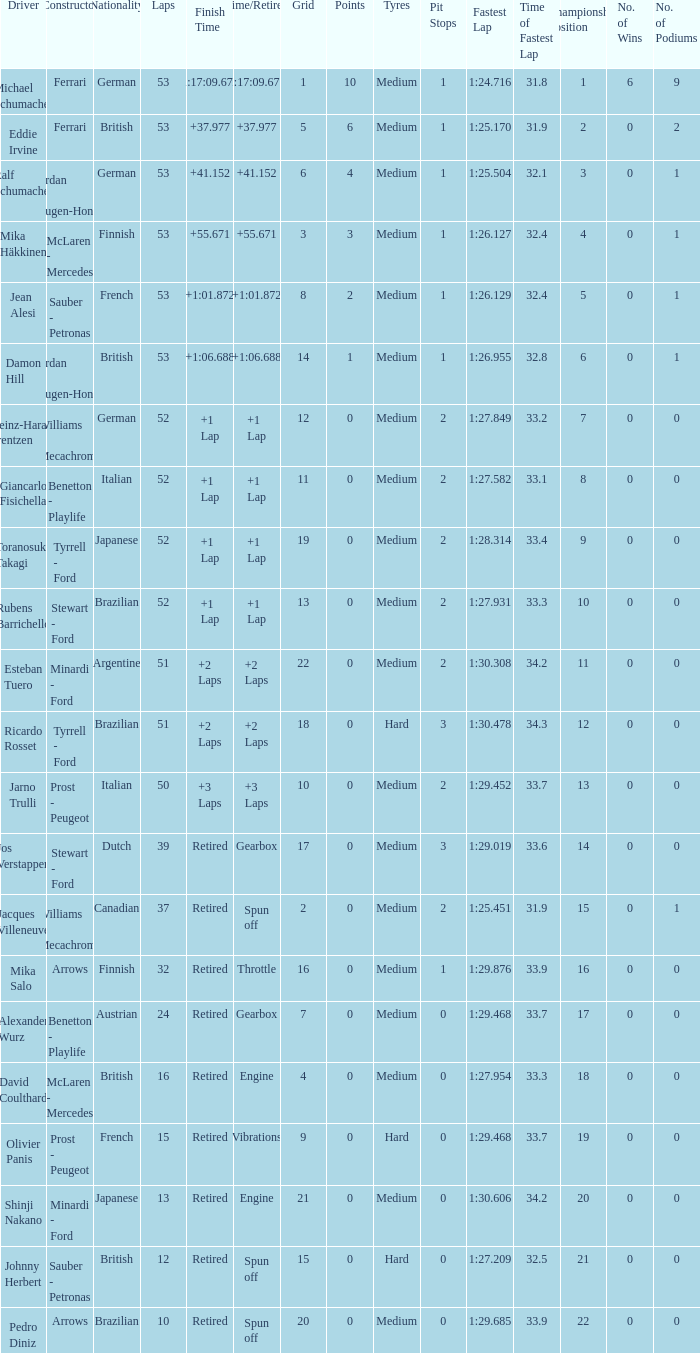Would you be able to parse every entry in this table? {'header': ['Driver', 'Constructor', 'Nationality', 'Laps', 'Finish Time', 'Time/Retired', 'Grid', 'Points', 'Tyres', 'Pit Stops', 'Fastest Lap', 'Time of Fastest Lap', 'Championship Position', 'No. of Wins', 'No. of Podiums'], 'rows': [['Michael Schumacher', 'Ferrari', 'German', '53', '1:17:09.672', '1:17:09.672', '1', '10', 'Medium', '1', '1:24.716', '31.8', '1', '6', '9'], ['Eddie Irvine', 'Ferrari', 'British', '53', '+37.977', '+37.977', '5', '6', 'Medium', '1', '1:25.170', '31.9', '2', '0', '2'], ['Ralf Schumacher', 'Jordan - Mugen-Honda', 'German', '53', '+41.152', '+41.152', '6', '4', 'Medium', '1', '1:25.504', '32.1', '3', '0', '1'], ['Mika Häkkinen', 'McLaren - Mercedes', 'Finnish', '53', '+55.671', '+55.671', '3', '3', 'Medium', '1', '1:26.127', '32.4', '4', '0', '1'], ['Jean Alesi', 'Sauber - Petronas', 'French', '53', '+1:01.872', '+1:01.872', '8', '2', 'Medium', '1', '1:26.129', '32.4', '5', '0', '1'], ['Damon Hill', 'Jordan - Mugen-Honda', 'British', '53', '+1:06.688', '+1:06.688', '14', '1', 'Medium', '1', '1:26.955', '32.8', '6', '0', '1'], ['Heinz-Harald Frentzen', 'Williams - Mecachrome', 'German', '52', '+1 Lap', '+1 Lap', '12', '0', 'Medium', '2', '1:27.849', '33.2', '7', '0', '0'], ['Giancarlo Fisichella', 'Benetton - Playlife', 'Italian', '52', '+1 Lap', '+1 Lap', '11', '0', 'Medium', '2', '1:27.582', '33.1', '8', '0', '0'], ['Toranosuke Takagi', 'Tyrrell - Ford', 'Japanese', '52', '+1 Lap', '+1 Lap', '19', '0', 'Medium', '2', '1:28.314', '33.4', '9', '0', '0'], ['Rubens Barrichello', 'Stewart - Ford', 'Brazilian', '52', '+1 Lap', '+1 Lap', '13', '0', 'Medium', '2', '1:27.931', '33.3', '10', '0', '0'], ['Esteban Tuero', 'Minardi - Ford', 'Argentine', '51', '+2 Laps', '+2 Laps', '22', '0', 'Medium', '2', '1:30.308', '34.2', '11', '0', '0'], ['Ricardo Rosset', 'Tyrrell - Ford', 'Brazilian', '51', '+2 Laps', '+2 Laps', '18', '0', 'Hard', '3', '1:30.478', '34.3', '12', '0', '0'], ['Jarno Trulli', 'Prost - Peugeot', 'Italian', '50', '+3 Laps', '+3 Laps', '10', '0', 'Medium', '2', '1:29.452', '33.7', '13', '0', '0'], ['Jos Verstappen', 'Stewart - Ford', 'Dutch', '39', 'Retired', 'Gearbox', '17', '0', 'Medium', '3', '1:29.019', '33.6', '14', '0', '0'], ['Jacques Villeneuve', 'Williams - Mecachrome', 'Canadian', '37', 'Retired', 'Spun off', '2', '0', 'Medium', '2', '1:25.451', '31.9', '15', '0', '1'], ['Mika Salo', 'Arrows', 'Finnish', '32', 'Retired', 'Throttle', '16', '0', 'Medium', '1', '1:29.876', '33.9', '16', '0', '0'], ['Alexander Wurz', 'Benetton - Playlife', 'Austrian', '24', 'Retired', 'Gearbox', '7', '0', 'Medium', '0', '1:29.468', '33.7', '17', '0', '0'], ['David Coulthard', 'McLaren - Mercedes', 'British', '16', 'Retired', 'Engine', '4', '0', 'Medium', '0', '1:27.954', '33.3', '18', '0', '0'], ['Olivier Panis', 'Prost - Peugeot', 'French', '15', 'Retired', 'Vibrations', '9', '0', 'Hard', '0', '1:29.468', '33.7', '19', '0', '0'], ['Shinji Nakano', 'Minardi - Ford', 'Japanese', '13', 'Retired', 'Engine', '21', '0', 'Medium', '0', '1:30.606', '34.2', '20', '0', '0'], ['Johnny Herbert', 'Sauber - Petronas', 'British', '12', 'Retired', 'Spun off', '15', '0', 'Hard', '0', '1:27.209', '32.5', '21', '0', '0'], ['Pedro Diniz', 'Arrows', 'Brazilian', '10', 'Retired', 'Spun off', '20', '0', 'Medium', '0', '1:29.685', '33.9', '22', '0', '0']]} What is the high lap total for pedro diniz? 10.0. 